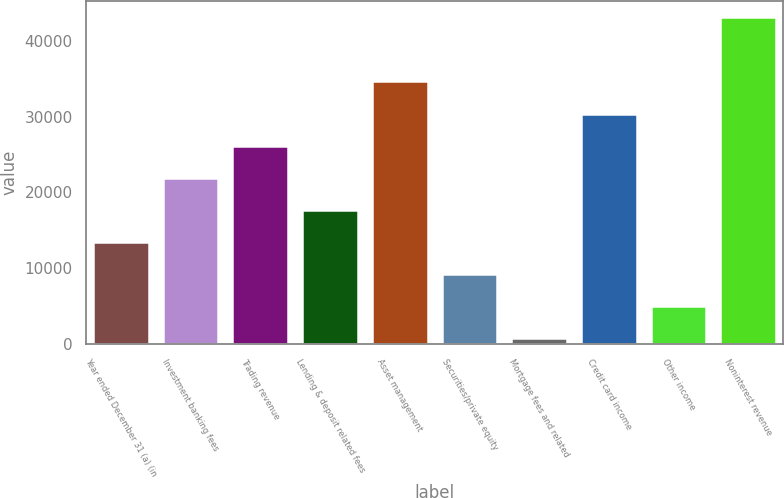Convert chart to OTSL. <chart><loc_0><loc_0><loc_500><loc_500><bar_chart><fcel>Year ended December 31 (a) (in<fcel>Investment banking fees<fcel>Trading revenue<fcel>Lending & deposit related fees<fcel>Asset management<fcel>Securities/private equity<fcel>Mortgage fees and related<fcel>Credit card income<fcel>Other income<fcel>Noninterest revenue<nl><fcel>13493.3<fcel>21951.5<fcel>26180.6<fcel>17722.4<fcel>34638.8<fcel>9264.2<fcel>806<fcel>30409.7<fcel>5035.1<fcel>43097<nl></chart> 